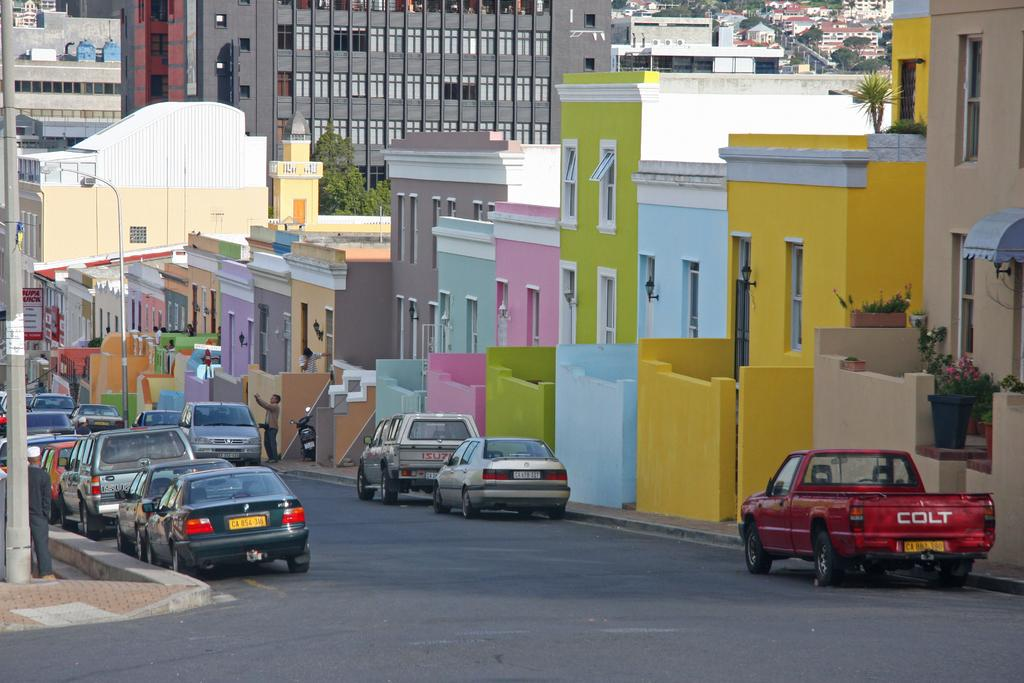<image>
Give a short and clear explanation of the subsequent image. A red pickup truck parked on the street reads COLT on the tailgate. 